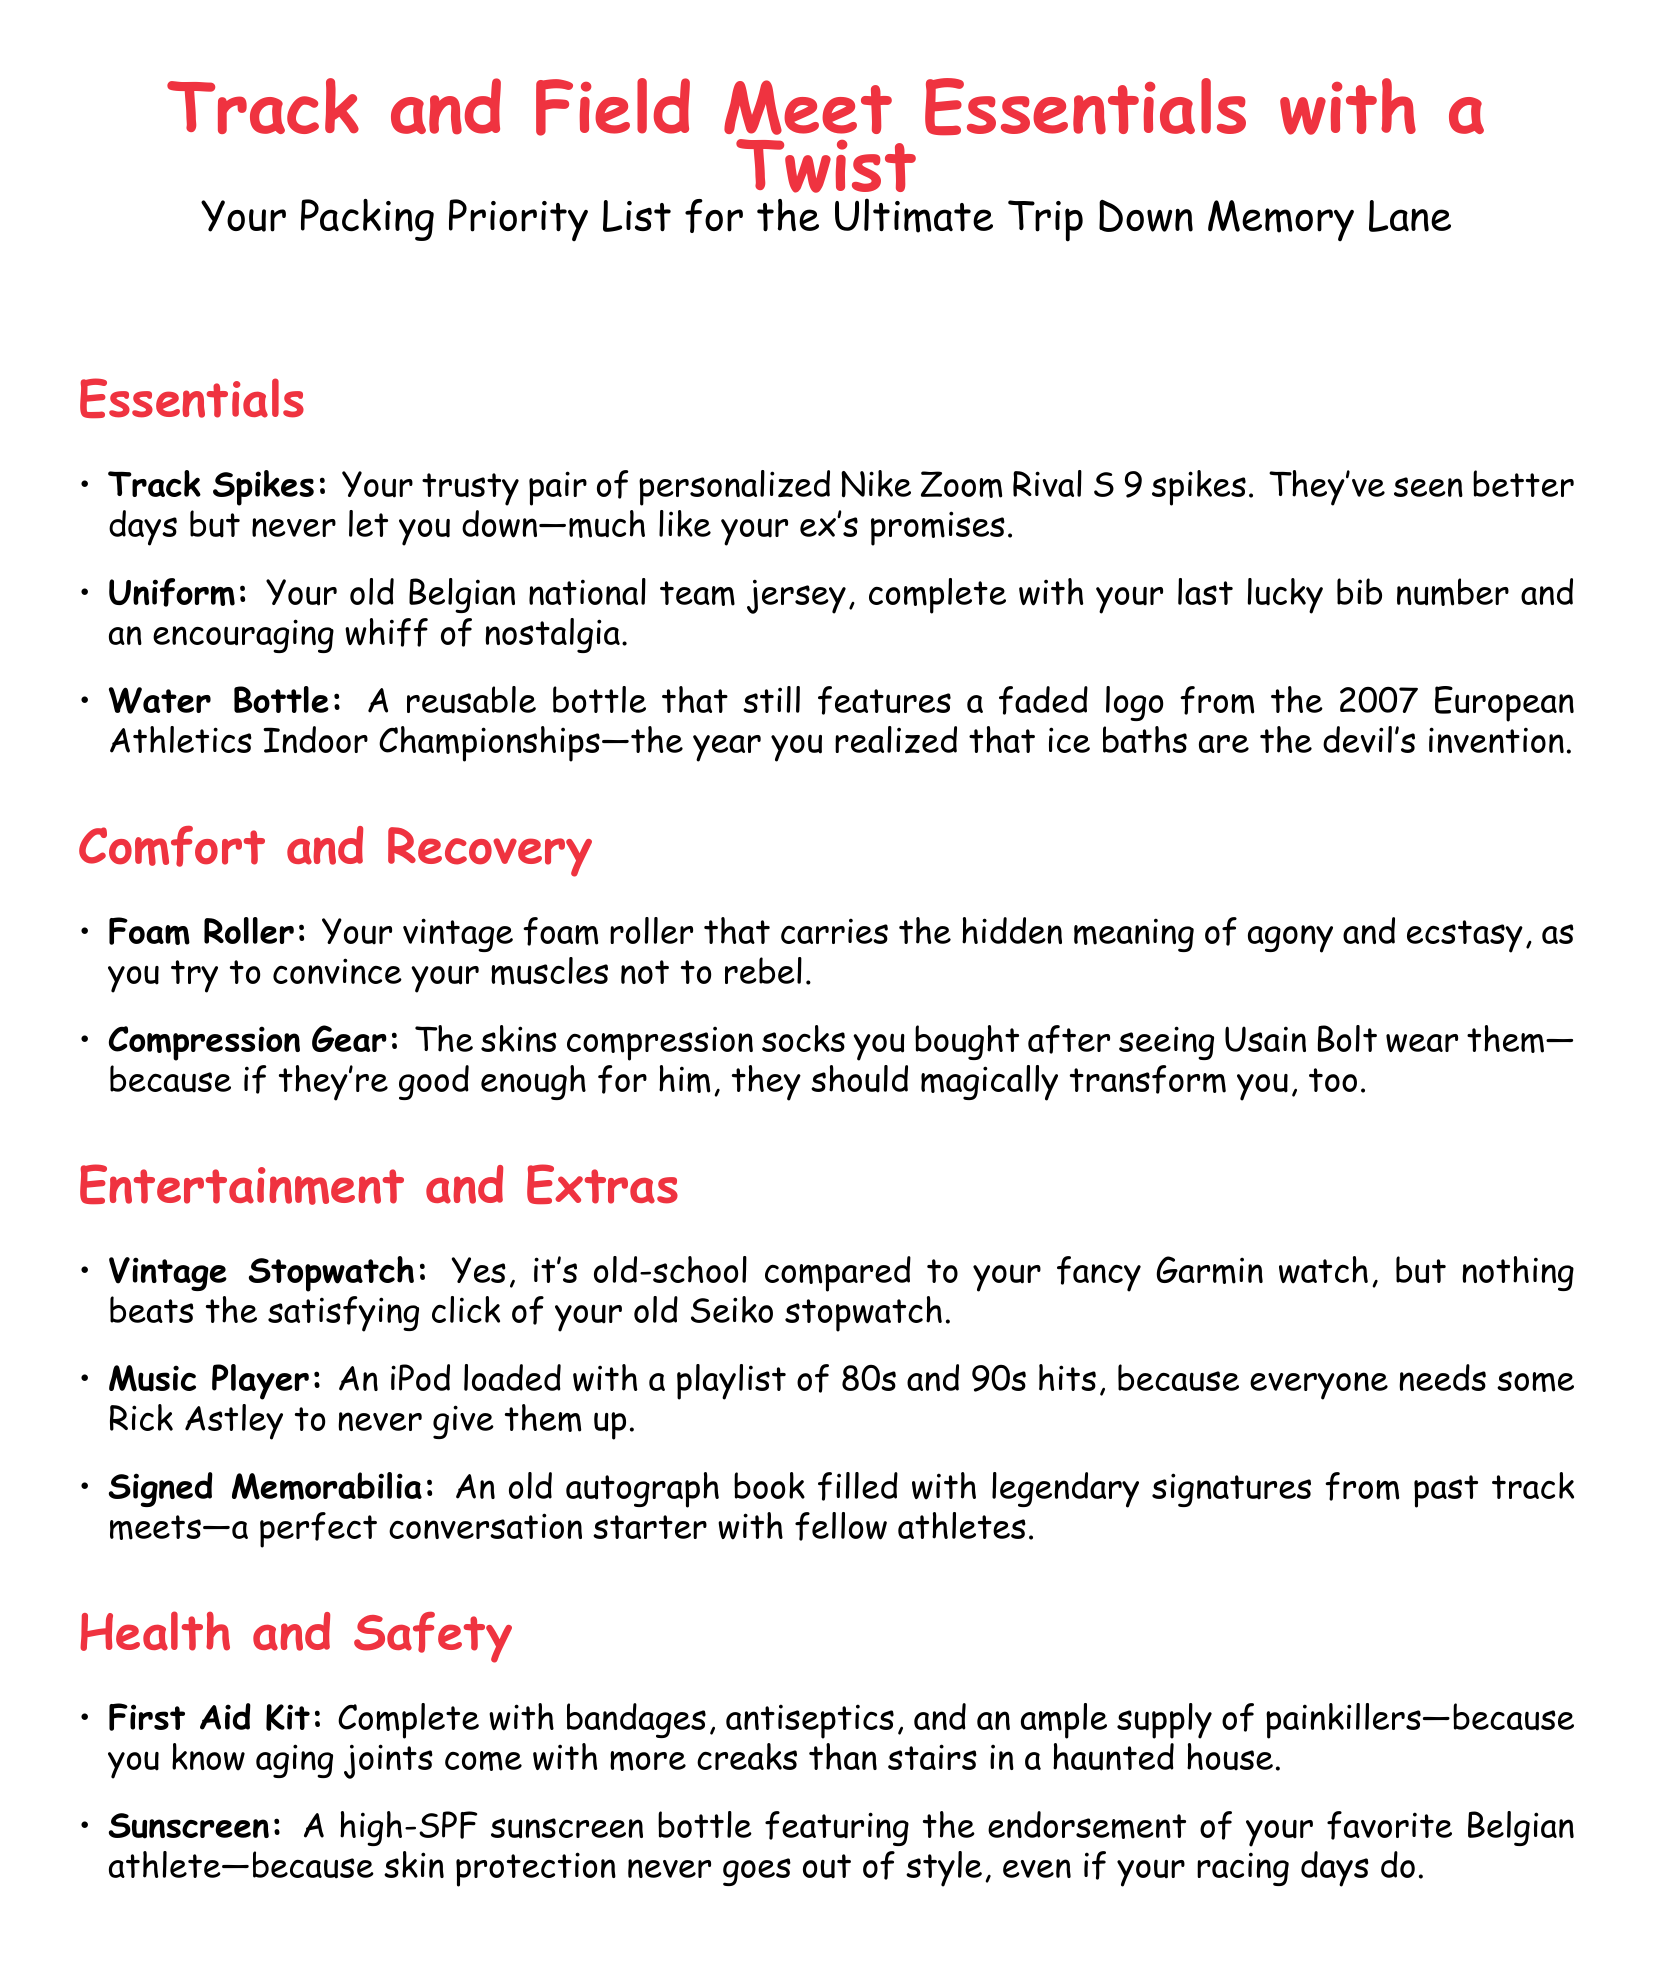What features do the track spikes have? The track spikes are described as trusty, personalized, and from Nike.
Answer: Personalized Nike Zoom Rival S 9 spikes What memorable year is associated with the water bottle? The water bottle features a faded logo from 2007, indicating it's linked to that year.
Answer: 2007 Which compression gear inspired the item in the list? The compression socks were inspired by Usain Bolt, a famous track athlete.
Answer: Usain Bolt What type of device is mentioned for timing? The document refers to an old Seiko stopwatch, indicating it's a timing device.
Answer: Vintage Stopwatch What is the purpose of the first aid kit listed? The first aid kit is meant for health emergencies and muscle care, particularly for aging athletes.
Answer: Aging joints What does the author's iPod playlist consist of? The iPod playlist is specifically filled with hits from the 80s and 90s.
Answer: 80s and 90s hits What type of memorabilia is considered a conversation starter? The signed memorabilia mentioned is an old autograph book.
Answer: Old autograph book Which skin product is highlighted for protection? Sunscreen is emphasized for skin protection, especially for athletes.
Answer: High-SPF sunscreen 